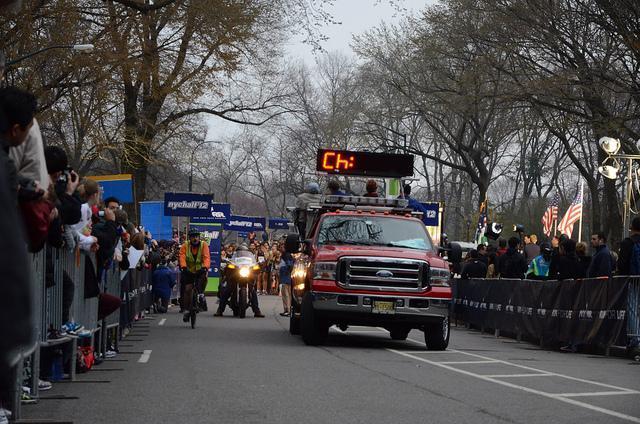How many flags can you see?
Give a very brief answer. 2. How many people can you see?
Give a very brief answer. 3. 